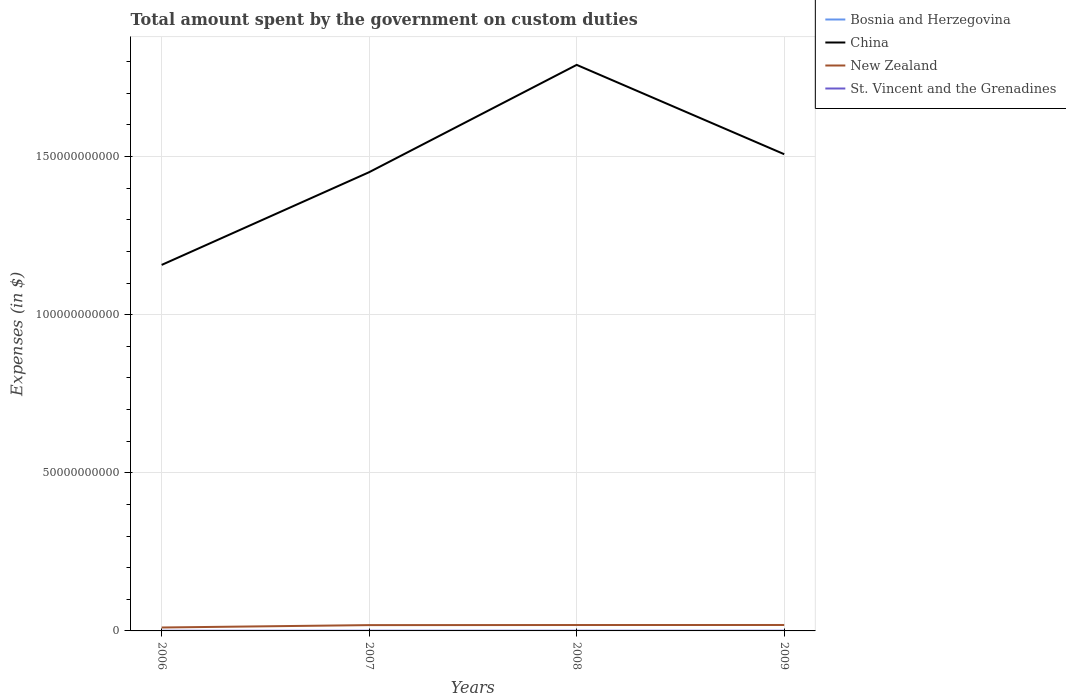How many different coloured lines are there?
Your answer should be very brief. 4. Across all years, what is the maximum amount spent on custom duties by the government in Bosnia and Herzegovina?
Your response must be concise. 7.27e+05. In which year was the amount spent on custom duties by the government in China maximum?
Your answer should be compact. 2006. What is the total amount spent on custom duties by the government in China in the graph?
Offer a very short reply. -3.50e+1. What is the difference between the highest and the second highest amount spent on custom duties by the government in Bosnia and Herzegovina?
Keep it short and to the point. 4.43e+06. Is the amount spent on custom duties by the government in St. Vincent and the Grenadines strictly greater than the amount spent on custom duties by the government in Bosnia and Herzegovina over the years?
Make the answer very short. No. How many lines are there?
Keep it short and to the point. 4. Does the graph contain any zero values?
Give a very brief answer. No. What is the title of the graph?
Your response must be concise. Total amount spent by the government on custom duties. What is the label or title of the Y-axis?
Give a very brief answer. Expenses (in $). What is the Expenses (in $) of Bosnia and Herzegovina in 2006?
Provide a succinct answer. 1.86e+06. What is the Expenses (in $) in China in 2006?
Offer a terse response. 1.16e+11. What is the Expenses (in $) in New Zealand in 2006?
Keep it short and to the point. 1.08e+09. What is the Expenses (in $) of St. Vincent and the Grenadines in 2006?
Provide a succinct answer. 3.51e+07. What is the Expenses (in $) in Bosnia and Herzegovina in 2007?
Provide a succinct answer. 5.15e+06. What is the Expenses (in $) of China in 2007?
Give a very brief answer. 1.45e+11. What is the Expenses (in $) in New Zealand in 2007?
Offer a terse response. 1.84e+09. What is the Expenses (in $) in St. Vincent and the Grenadines in 2007?
Your response must be concise. 4.39e+07. What is the Expenses (in $) of Bosnia and Herzegovina in 2008?
Give a very brief answer. 3.23e+06. What is the Expenses (in $) in China in 2008?
Ensure brevity in your answer.  1.79e+11. What is the Expenses (in $) of New Zealand in 2008?
Make the answer very short. 1.87e+09. What is the Expenses (in $) in St. Vincent and the Grenadines in 2008?
Provide a succinct answer. 4.56e+07. What is the Expenses (in $) in Bosnia and Herzegovina in 2009?
Give a very brief answer. 7.27e+05. What is the Expenses (in $) of China in 2009?
Offer a terse response. 1.51e+11. What is the Expenses (in $) of New Zealand in 2009?
Your answer should be very brief. 1.88e+09. What is the Expenses (in $) in St. Vincent and the Grenadines in 2009?
Offer a very short reply. 4.62e+07. Across all years, what is the maximum Expenses (in $) of Bosnia and Herzegovina?
Keep it short and to the point. 5.15e+06. Across all years, what is the maximum Expenses (in $) of China?
Your answer should be very brief. 1.79e+11. Across all years, what is the maximum Expenses (in $) in New Zealand?
Keep it short and to the point. 1.88e+09. Across all years, what is the maximum Expenses (in $) of St. Vincent and the Grenadines?
Your answer should be very brief. 4.62e+07. Across all years, what is the minimum Expenses (in $) of Bosnia and Herzegovina?
Offer a terse response. 7.27e+05. Across all years, what is the minimum Expenses (in $) of China?
Make the answer very short. 1.16e+11. Across all years, what is the minimum Expenses (in $) of New Zealand?
Provide a short and direct response. 1.08e+09. Across all years, what is the minimum Expenses (in $) of St. Vincent and the Grenadines?
Offer a terse response. 3.51e+07. What is the total Expenses (in $) in Bosnia and Herzegovina in the graph?
Provide a short and direct response. 1.10e+07. What is the total Expenses (in $) in China in the graph?
Your response must be concise. 5.91e+11. What is the total Expenses (in $) of New Zealand in the graph?
Make the answer very short. 6.67e+09. What is the total Expenses (in $) of St. Vincent and the Grenadines in the graph?
Your answer should be compact. 1.71e+08. What is the difference between the Expenses (in $) in Bosnia and Herzegovina in 2006 and that in 2007?
Provide a short and direct response. -3.30e+06. What is the difference between the Expenses (in $) in China in 2006 and that in 2007?
Make the answer very short. -2.93e+1. What is the difference between the Expenses (in $) of New Zealand in 2006 and that in 2007?
Make the answer very short. -7.53e+08. What is the difference between the Expenses (in $) of St. Vincent and the Grenadines in 2006 and that in 2007?
Ensure brevity in your answer.  -8.80e+06. What is the difference between the Expenses (in $) of Bosnia and Herzegovina in 2006 and that in 2008?
Offer a terse response. -1.38e+06. What is the difference between the Expenses (in $) of China in 2006 and that in 2008?
Your answer should be compact. -6.33e+1. What is the difference between the Expenses (in $) of New Zealand in 2006 and that in 2008?
Give a very brief answer. -7.86e+08. What is the difference between the Expenses (in $) in St. Vincent and the Grenadines in 2006 and that in 2008?
Give a very brief answer. -1.05e+07. What is the difference between the Expenses (in $) in Bosnia and Herzegovina in 2006 and that in 2009?
Offer a terse response. 1.13e+06. What is the difference between the Expenses (in $) in China in 2006 and that in 2009?
Offer a very short reply. -3.50e+1. What is the difference between the Expenses (in $) of New Zealand in 2006 and that in 2009?
Make the answer very short. -7.97e+08. What is the difference between the Expenses (in $) of St. Vincent and the Grenadines in 2006 and that in 2009?
Give a very brief answer. -1.11e+07. What is the difference between the Expenses (in $) of Bosnia and Herzegovina in 2007 and that in 2008?
Your response must be concise. 1.92e+06. What is the difference between the Expenses (in $) in China in 2007 and that in 2008?
Ensure brevity in your answer.  -3.39e+1. What is the difference between the Expenses (in $) in New Zealand in 2007 and that in 2008?
Keep it short and to the point. -3.32e+07. What is the difference between the Expenses (in $) in St. Vincent and the Grenadines in 2007 and that in 2008?
Ensure brevity in your answer.  -1.70e+06. What is the difference between the Expenses (in $) in Bosnia and Herzegovina in 2007 and that in 2009?
Ensure brevity in your answer.  4.43e+06. What is the difference between the Expenses (in $) in China in 2007 and that in 2009?
Make the answer very short. -5.68e+09. What is the difference between the Expenses (in $) in New Zealand in 2007 and that in 2009?
Ensure brevity in your answer.  -4.38e+07. What is the difference between the Expenses (in $) in St. Vincent and the Grenadines in 2007 and that in 2009?
Ensure brevity in your answer.  -2.30e+06. What is the difference between the Expenses (in $) in Bosnia and Herzegovina in 2008 and that in 2009?
Make the answer very short. 2.51e+06. What is the difference between the Expenses (in $) of China in 2008 and that in 2009?
Provide a short and direct response. 2.83e+1. What is the difference between the Expenses (in $) in New Zealand in 2008 and that in 2009?
Provide a succinct answer. -1.07e+07. What is the difference between the Expenses (in $) in St. Vincent and the Grenadines in 2008 and that in 2009?
Ensure brevity in your answer.  -6.00e+05. What is the difference between the Expenses (in $) of Bosnia and Herzegovina in 2006 and the Expenses (in $) of China in 2007?
Your answer should be compact. -1.45e+11. What is the difference between the Expenses (in $) in Bosnia and Herzegovina in 2006 and the Expenses (in $) in New Zealand in 2007?
Offer a very short reply. -1.83e+09. What is the difference between the Expenses (in $) of Bosnia and Herzegovina in 2006 and the Expenses (in $) of St. Vincent and the Grenadines in 2007?
Provide a succinct answer. -4.20e+07. What is the difference between the Expenses (in $) of China in 2006 and the Expenses (in $) of New Zealand in 2007?
Your answer should be very brief. 1.14e+11. What is the difference between the Expenses (in $) in China in 2006 and the Expenses (in $) in St. Vincent and the Grenadines in 2007?
Your response must be concise. 1.16e+11. What is the difference between the Expenses (in $) of New Zealand in 2006 and the Expenses (in $) of St. Vincent and the Grenadines in 2007?
Provide a short and direct response. 1.04e+09. What is the difference between the Expenses (in $) of Bosnia and Herzegovina in 2006 and the Expenses (in $) of China in 2008?
Keep it short and to the point. -1.79e+11. What is the difference between the Expenses (in $) of Bosnia and Herzegovina in 2006 and the Expenses (in $) of New Zealand in 2008?
Keep it short and to the point. -1.87e+09. What is the difference between the Expenses (in $) of Bosnia and Herzegovina in 2006 and the Expenses (in $) of St. Vincent and the Grenadines in 2008?
Offer a terse response. -4.37e+07. What is the difference between the Expenses (in $) in China in 2006 and the Expenses (in $) in New Zealand in 2008?
Give a very brief answer. 1.14e+11. What is the difference between the Expenses (in $) in China in 2006 and the Expenses (in $) in St. Vincent and the Grenadines in 2008?
Make the answer very short. 1.16e+11. What is the difference between the Expenses (in $) in New Zealand in 2006 and the Expenses (in $) in St. Vincent and the Grenadines in 2008?
Your answer should be compact. 1.04e+09. What is the difference between the Expenses (in $) in Bosnia and Herzegovina in 2006 and the Expenses (in $) in China in 2009?
Provide a succinct answer. -1.51e+11. What is the difference between the Expenses (in $) of Bosnia and Herzegovina in 2006 and the Expenses (in $) of New Zealand in 2009?
Keep it short and to the point. -1.88e+09. What is the difference between the Expenses (in $) of Bosnia and Herzegovina in 2006 and the Expenses (in $) of St. Vincent and the Grenadines in 2009?
Offer a terse response. -4.43e+07. What is the difference between the Expenses (in $) in China in 2006 and the Expenses (in $) in New Zealand in 2009?
Offer a terse response. 1.14e+11. What is the difference between the Expenses (in $) in China in 2006 and the Expenses (in $) in St. Vincent and the Grenadines in 2009?
Your answer should be very brief. 1.16e+11. What is the difference between the Expenses (in $) in New Zealand in 2006 and the Expenses (in $) in St. Vincent and the Grenadines in 2009?
Offer a very short reply. 1.04e+09. What is the difference between the Expenses (in $) of Bosnia and Herzegovina in 2007 and the Expenses (in $) of China in 2008?
Keep it short and to the point. -1.79e+11. What is the difference between the Expenses (in $) in Bosnia and Herzegovina in 2007 and the Expenses (in $) in New Zealand in 2008?
Your answer should be very brief. -1.86e+09. What is the difference between the Expenses (in $) in Bosnia and Herzegovina in 2007 and the Expenses (in $) in St. Vincent and the Grenadines in 2008?
Provide a short and direct response. -4.04e+07. What is the difference between the Expenses (in $) in China in 2007 and the Expenses (in $) in New Zealand in 2008?
Provide a succinct answer. 1.43e+11. What is the difference between the Expenses (in $) of China in 2007 and the Expenses (in $) of St. Vincent and the Grenadines in 2008?
Offer a terse response. 1.45e+11. What is the difference between the Expenses (in $) in New Zealand in 2007 and the Expenses (in $) in St. Vincent and the Grenadines in 2008?
Make the answer very short. 1.79e+09. What is the difference between the Expenses (in $) of Bosnia and Herzegovina in 2007 and the Expenses (in $) of China in 2009?
Your answer should be compact. -1.51e+11. What is the difference between the Expenses (in $) in Bosnia and Herzegovina in 2007 and the Expenses (in $) in New Zealand in 2009?
Your answer should be very brief. -1.87e+09. What is the difference between the Expenses (in $) of Bosnia and Herzegovina in 2007 and the Expenses (in $) of St. Vincent and the Grenadines in 2009?
Offer a very short reply. -4.10e+07. What is the difference between the Expenses (in $) of China in 2007 and the Expenses (in $) of New Zealand in 2009?
Your response must be concise. 1.43e+11. What is the difference between the Expenses (in $) in China in 2007 and the Expenses (in $) in St. Vincent and the Grenadines in 2009?
Your answer should be compact. 1.45e+11. What is the difference between the Expenses (in $) in New Zealand in 2007 and the Expenses (in $) in St. Vincent and the Grenadines in 2009?
Give a very brief answer. 1.79e+09. What is the difference between the Expenses (in $) in Bosnia and Herzegovina in 2008 and the Expenses (in $) in China in 2009?
Provide a succinct answer. -1.51e+11. What is the difference between the Expenses (in $) in Bosnia and Herzegovina in 2008 and the Expenses (in $) in New Zealand in 2009?
Provide a succinct answer. -1.88e+09. What is the difference between the Expenses (in $) of Bosnia and Herzegovina in 2008 and the Expenses (in $) of St. Vincent and the Grenadines in 2009?
Make the answer very short. -4.30e+07. What is the difference between the Expenses (in $) in China in 2008 and the Expenses (in $) in New Zealand in 2009?
Provide a short and direct response. 1.77e+11. What is the difference between the Expenses (in $) in China in 2008 and the Expenses (in $) in St. Vincent and the Grenadines in 2009?
Your answer should be compact. 1.79e+11. What is the difference between the Expenses (in $) in New Zealand in 2008 and the Expenses (in $) in St. Vincent and the Grenadines in 2009?
Offer a very short reply. 1.82e+09. What is the average Expenses (in $) of Bosnia and Herzegovina per year?
Your answer should be compact. 2.74e+06. What is the average Expenses (in $) in China per year?
Offer a very short reply. 1.48e+11. What is the average Expenses (in $) of New Zealand per year?
Keep it short and to the point. 1.67e+09. What is the average Expenses (in $) of St. Vincent and the Grenadines per year?
Ensure brevity in your answer.  4.27e+07. In the year 2006, what is the difference between the Expenses (in $) in Bosnia and Herzegovina and Expenses (in $) in China?
Ensure brevity in your answer.  -1.16e+11. In the year 2006, what is the difference between the Expenses (in $) of Bosnia and Herzegovina and Expenses (in $) of New Zealand?
Your response must be concise. -1.08e+09. In the year 2006, what is the difference between the Expenses (in $) in Bosnia and Herzegovina and Expenses (in $) in St. Vincent and the Grenadines?
Ensure brevity in your answer.  -3.32e+07. In the year 2006, what is the difference between the Expenses (in $) of China and Expenses (in $) of New Zealand?
Make the answer very short. 1.15e+11. In the year 2006, what is the difference between the Expenses (in $) in China and Expenses (in $) in St. Vincent and the Grenadines?
Offer a very short reply. 1.16e+11. In the year 2006, what is the difference between the Expenses (in $) in New Zealand and Expenses (in $) in St. Vincent and the Grenadines?
Make the answer very short. 1.05e+09. In the year 2007, what is the difference between the Expenses (in $) in Bosnia and Herzegovina and Expenses (in $) in China?
Your response must be concise. -1.45e+11. In the year 2007, what is the difference between the Expenses (in $) of Bosnia and Herzegovina and Expenses (in $) of New Zealand?
Ensure brevity in your answer.  -1.83e+09. In the year 2007, what is the difference between the Expenses (in $) of Bosnia and Herzegovina and Expenses (in $) of St. Vincent and the Grenadines?
Offer a very short reply. -3.87e+07. In the year 2007, what is the difference between the Expenses (in $) of China and Expenses (in $) of New Zealand?
Offer a terse response. 1.43e+11. In the year 2007, what is the difference between the Expenses (in $) of China and Expenses (in $) of St. Vincent and the Grenadines?
Your response must be concise. 1.45e+11. In the year 2007, what is the difference between the Expenses (in $) of New Zealand and Expenses (in $) of St. Vincent and the Grenadines?
Your response must be concise. 1.79e+09. In the year 2008, what is the difference between the Expenses (in $) of Bosnia and Herzegovina and Expenses (in $) of China?
Give a very brief answer. -1.79e+11. In the year 2008, what is the difference between the Expenses (in $) of Bosnia and Herzegovina and Expenses (in $) of New Zealand?
Your response must be concise. -1.87e+09. In the year 2008, what is the difference between the Expenses (in $) in Bosnia and Herzegovina and Expenses (in $) in St. Vincent and the Grenadines?
Make the answer very short. -4.24e+07. In the year 2008, what is the difference between the Expenses (in $) of China and Expenses (in $) of New Zealand?
Ensure brevity in your answer.  1.77e+11. In the year 2008, what is the difference between the Expenses (in $) of China and Expenses (in $) of St. Vincent and the Grenadines?
Offer a very short reply. 1.79e+11. In the year 2008, what is the difference between the Expenses (in $) in New Zealand and Expenses (in $) in St. Vincent and the Grenadines?
Your answer should be very brief. 1.82e+09. In the year 2009, what is the difference between the Expenses (in $) of Bosnia and Herzegovina and Expenses (in $) of China?
Give a very brief answer. -1.51e+11. In the year 2009, what is the difference between the Expenses (in $) in Bosnia and Herzegovina and Expenses (in $) in New Zealand?
Your response must be concise. -1.88e+09. In the year 2009, what is the difference between the Expenses (in $) in Bosnia and Herzegovina and Expenses (in $) in St. Vincent and the Grenadines?
Provide a succinct answer. -4.55e+07. In the year 2009, what is the difference between the Expenses (in $) of China and Expenses (in $) of New Zealand?
Your answer should be compact. 1.49e+11. In the year 2009, what is the difference between the Expenses (in $) in China and Expenses (in $) in St. Vincent and the Grenadines?
Make the answer very short. 1.51e+11. In the year 2009, what is the difference between the Expenses (in $) of New Zealand and Expenses (in $) of St. Vincent and the Grenadines?
Your response must be concise. 1.83e+09. What is the ratio of the Expenses (in $) in Bosnia and Herzegovina in 2006 to that in 2007?
Give a very brief answer. 0.36. What is the ratio of the Expenses (in $) in China in 2006 to that in 2007?
Your response must be concise. 0.8. What is the ratio of the Expenses (in $) of New Zealand in 2006 to that in 2007?
Keep it short and to the point. 0.59. What is the ratio of the Expenses (in $) of St. Vincent and the Grenadines in 2006 to that in 2007?
Provide a short and direct response. 0.8. What is the ratio of the Expenses (in $) of Bosnia and Herzegovina in 2006 to that in 2008?
Keep it short and to the point. 0.57. What is the ratio of the Expenses (in $) in China in 2006 to that in 2008?
Ensure brevity in your answer.  0.65. What is the ratio of the Expenses (in $) of New Zealand in 2006 to that in 2008?
Make the answer very short. 0.58. What is the ratio of the Expenses (in $) in St. Vincent and the Grenadines in 2006 to that in 2008?
Your response must be concise. 0.77. What is the ratio of the Expenses (in $) of Bosnia and Herzegovina in 2006 to that in 2009?
Offer a very short reply. 2.55. What is the ratio of the Expenses (in $) in China in 2006 to that in 2009?
Offer a terse response. 0.77. What is the ratio of the Expenses (in $) of New Zealand in 2006 to that in 2009?
Your answer should be compact. 0.58. What is the ratio of the Expenses (in $) in St. Vincent and the Grenadines in 2006 to that in 2009?
Provide a succinct answer. 0.76. What is the ratio of the Expenses (in $) in Bosnia and Herzegovina in 2007 to that in 2008?
Your answer should be compact. 1.59. What is the ratio of the Expenses (in $) of China in 2007 to that in 2008?
Ensure brevity in your answer.  0.81. What is the ratio of the Expenses (in $) in New Zealand in 2007 to that in 2008?
Provide a succinct answer. 0.98. What is the ratio of the Expenses (in $) in St. Vincent and the Grenadines in 2007 to that in 2008?
Give a very brief answer. 0.96. What is the ratio of the Expenses (in $) in Bosnia and Herzegovina in 2007 to that in 2009?
Give a very brief answer. 7.09. What is the ratio of the Expenses (in $) of China in 2007 to that in 2009?
Provide a short and direct response. 0.96. What is the ratio of the Expenses (in $) of New Zealand in 2007 to that in 2009?
Your answer should be very brief. 0.98. What is the ratio of the Expenses (in $) of St. Vincent and the Grenadines in 2007 to that in 2009?
Give a very brief answer. 0.95. What is the ratio of the Expenses (in $) in Bosnia and Herzegovina in 2008 to that in 2009?
Provide a short and direct response. 4.45. What is the ratio of the Expenses (in $) of China in 2008 to that in 2009?
Your answer should be very brief. 1.19. What is the ratio of the Expenses (in $) of New Zealand in 2008 to that in 2009?
Your answer should be very brief. 0.99. What is the ratio of the Expenses (in $) in St. Vincent and the Grenadines in 2008 to that in 2009?
Ensure brevity in your answer.  0.99. What is the difference between the highest and the second highest Expenses (in $) in Bosnia and Herzegovina?
Offer a terse response. 1.92e+06. What is the difference between the highest and the second highest Expenses (in $) of China?
Ensure brevity in your answer.  2.83e+1. What is the difference between the highest and the second highest Expenses (in $) in New Zealand?
Offer a very short reply. 1.07e+07. What is the difference between the highest and the lowest Expenses (in $) of Bosnia and Herzegovina?
Your answer should be compact. 4.43e+06. What is the difference between the highest and the lowest Expenses (in $) of China?
Your answer should be compact. 6.33e+1. What is the difference between the highest and the lowest Expenses (in $) in New Zealand?
Keep it short and to the point. 7.97e+08. What is the difference between the highest and the lowest Expenses (in $) of St. Vincent and the Grenadines?
Provide a short and direct response. 1.11e+07. 